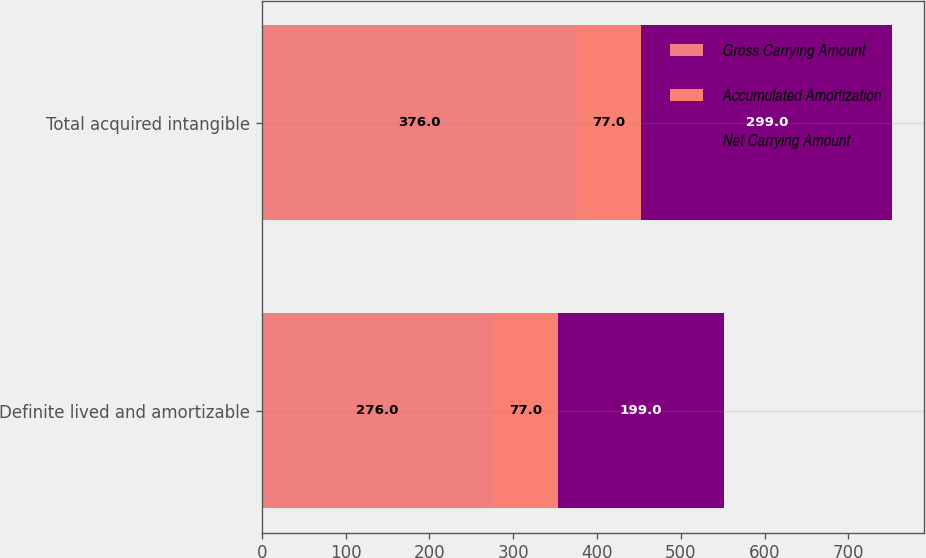Convert chart. <chart><loc_0><loc_0><loc_500><loc_500><stacked_bar_chart><ecel><fcel>Definite lived and amortizable<fcel>Total acquired intangible<nl><fcel>Gross Carrying Amount<fcel>276<fcel>376<nl><fcel>Accumulated Amortization<fcel>77<fcel>77<nl><fcel>Net Carrying Amount<fcel>199<fcel>299<nl></chart> 